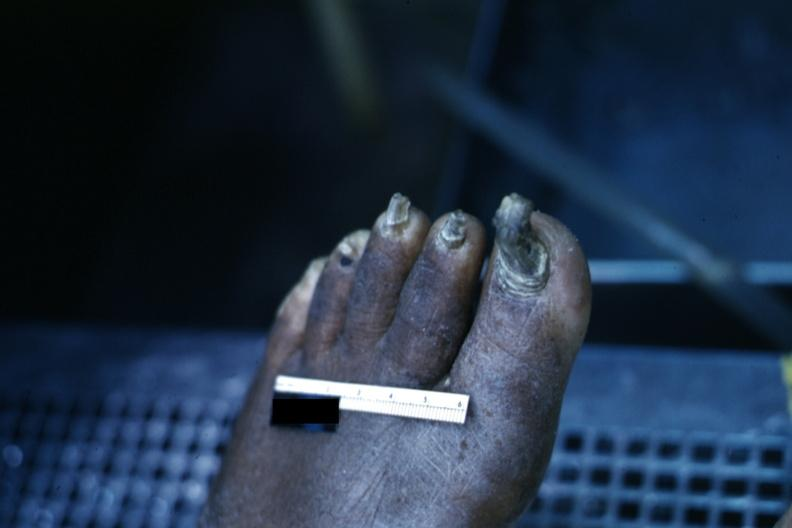what is present?
Answer the question using a single word or phrase. Trophic changes 